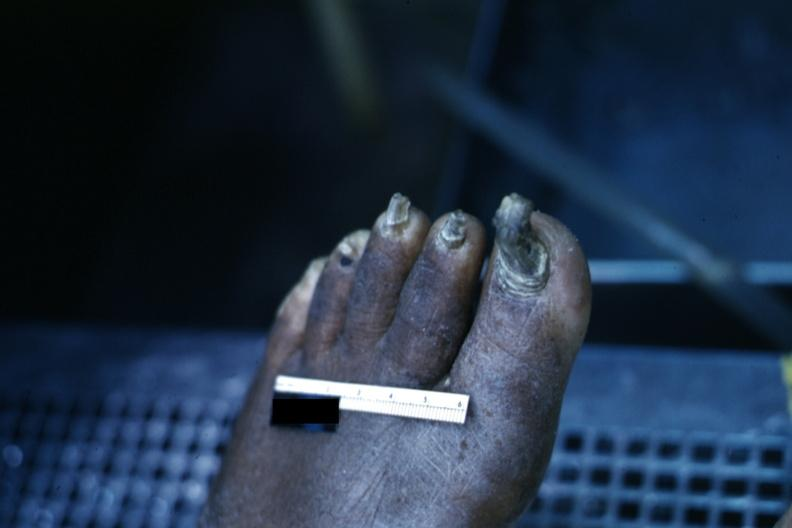what is present?
Answer the question using a single word or phrase. Trophic changes 